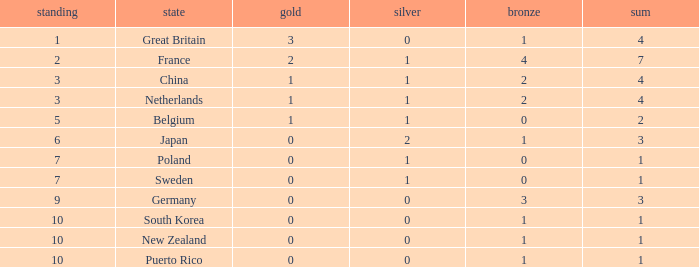What is the rank with 0 bronze? None. 